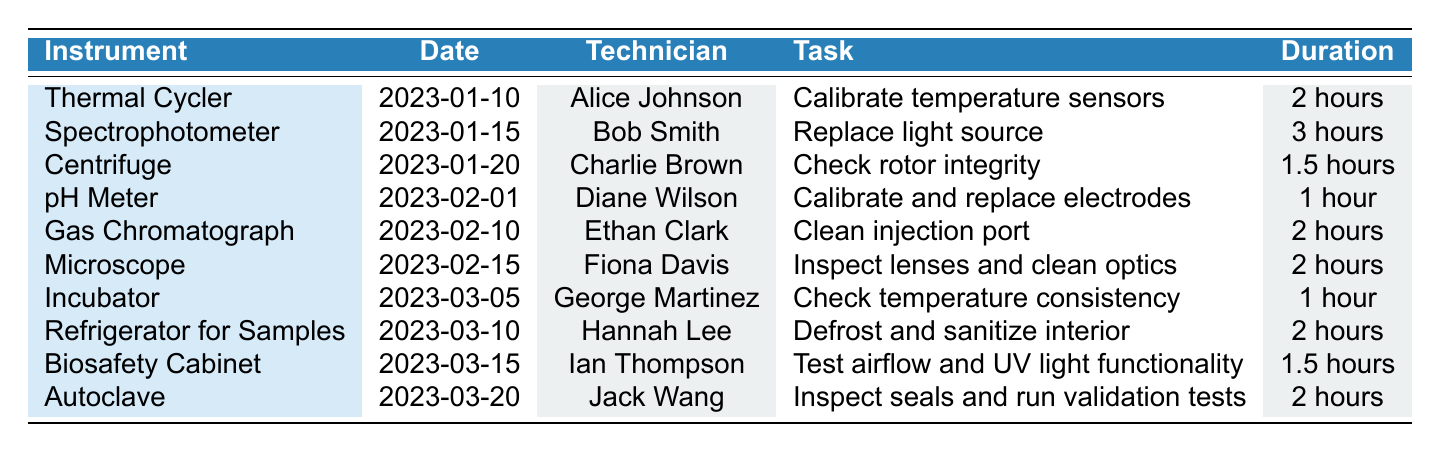What maintenance task is scheduled for the Gas Chromatograph? The table lists the maintenance tasks for each instrument; for the Gas Chromatograph, the task is to "Clean injection port."
Answer: Clean injection port Who is the technician assigned to the Spectrophotometer? According to the table, the technician assigned to the Spectrophotometer is Bob Smith.
Answer: Bob Smith How many hours of maintenance are required for the Centrifuge? The duration for the Centrifuge maintenance is listed in the table as "1.5 hours."
Answer: 1.5 hours What is the total duration of maintenance tasks scheduled for February? In February, there are three tasks: pH Meter (1 hour) + Gas Chromatograph (2 hours) + Microscope (2 hours) = 5 hours. Thus, the total duration is 5 hours.
Answer: 5 hours Is there a maintenance task scheduled for the Incubator in January? By checking the table, there is no maintenance task scheduled for the Incubator in January; it is scheduled for March instead.
Answer: No Which instrument has the longest maintenance duration, and how long is it? The longest maintenance duration in the table is for the Spectrophotometer, which requires "3 hours."
Answer: Spectrophotometer, 3 hours How many different technicians are involved in the maintenance tasks for the instruments? The table shows a total of 10 unique technicians: Alice Johnson, Bob Smith, Charlie Brown, Diane Wilson, Ethan Clark, Fiona Davis, George Martinez, Hannah Lee, Ian Thompson, and Jack Wang, which gives us 10 in total.
Answer: 10 Which instrument is scheduled for maintenance on March 15? The table indicates that on March 15, maintenance is scheduled for the Biosafety Cabinet.
Answer: Biosafety Cabinet What is the average duration of maintenance tasks for all instruments listed? By summing the durations of all maintenance tasks: 2 + 3 + 1.5 + 1 + 2 + 2 + 1 + 2 + 1.5 + 2 = 18 hours. Then, dividing by the number of tasks (10), the average duration is 18 / 10 = 1.8 hours.
Answer: 1.8 hours 